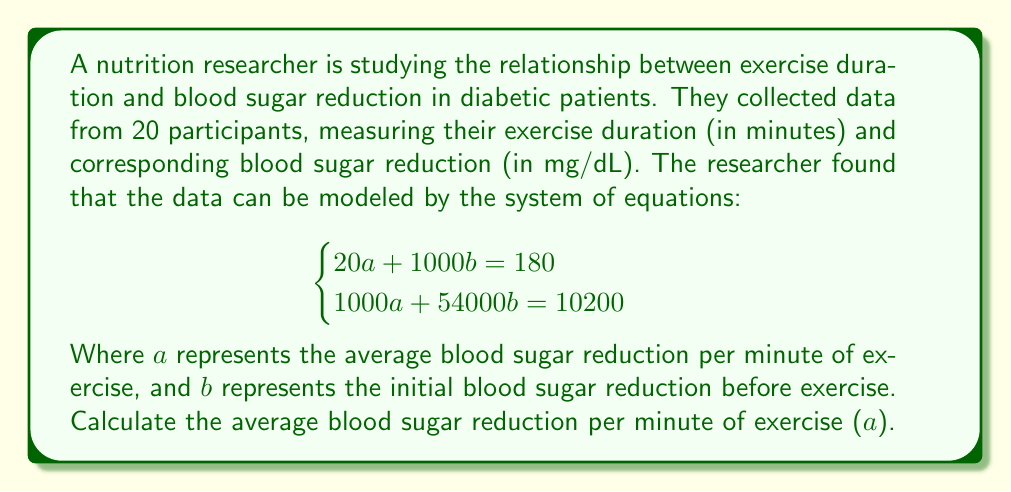Show me your answer to this math problem. To solve this system of equations, we'll use the elimination method:

1) Multiply the first equation by 50:
   $$1000a + 50000b = 9000$$

2) Subtract this from the second equation:
   $$(1000a + 54000b = 10200) - (1000a + 50000b = 9000)$$
   $$4000b = 1200$$

3) Solve for $b$:
   $$b = \frac{1200}{4000} = 0.3$$

4) Substitute this value of $b$ into the first equation:
   $$20a + 1000(0.3) = 180$$
   $$20a + 300 = 180$$
   $$20a = -120$$

5) Solve for $a$:
   $$a = \frac{-120}{20} = -6$$

Therefore, the average blood sugar reduction per minute of exercise ($a$) is -6 mg/dL/min.
Answer: -6 mg/dL/min 